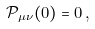Convert formula to latex. <formula><loc_0><loc_0><loc_500><loc_500>\mathcal { P } _ { \mu \nu } ( 0 ) = 0 \, ,</formula> 